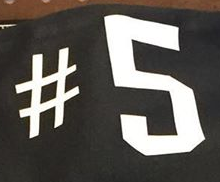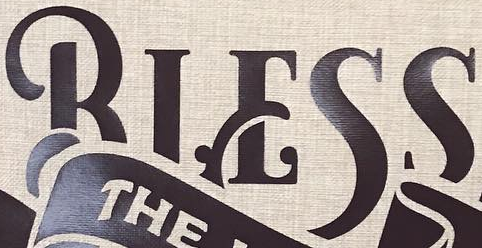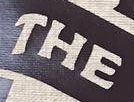Read the text from these images in sequence, separated by a semicolon. #5; BIESS; THE 